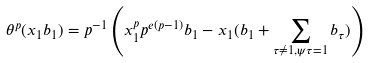<formula> <loc_0><loc_0><loc_500><loc_500>\theta ^ { p } ( x _ { 1 } b _ { 1 } ) = p ^ { - 1 } \left ( x _ { 1 } ^ { p } p ^ { e ( p - 1 ) } b _ { 1 } - x _ { 1 } ( b _ { 1 } + \sum _ { \tau \not = 1 , \psi \tau = 1 } b _ { \tau } ) \right )</formula> 